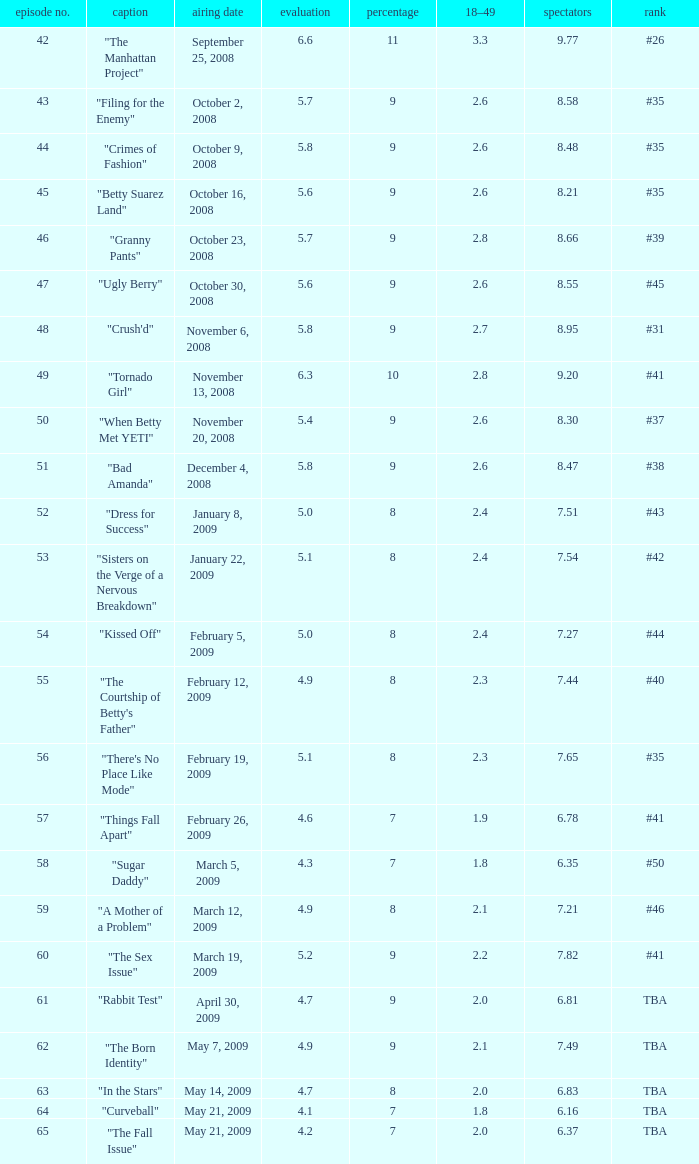What is the average Episode # with a 7 share and 18–49 is less than 2 and the Air Date of may 21, 2009? 64.0. 